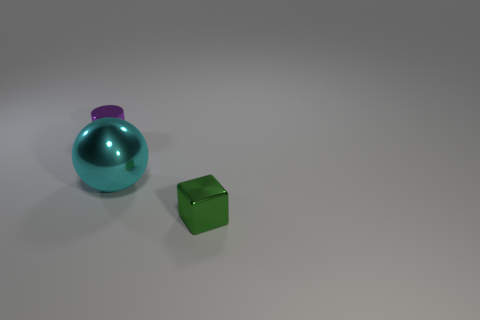The small thing right of the big cyan shiny sphere is what color?
Keep it short and to the point. Green. Are there more tiny shiny things left of the green metal object than tiny purple rubber blocks?
Provide a short and direct response. Yes. What is the color of the tiny block?
Offer a very short reply. Green. What is the shape of the small metal object that is on the left side of the small metal thing right of the tiny object that is behind the small green metal block?
Provide a short and direct response. Cylinder. There is a thing that is on the right side of the cylinder and left of the tiny green metal object; what material is it?
Keep it short and to the point. Metal. There is a small metal object on the right side of the tiny shiny thing left of the cyan metallic object; what is its shape?
Give a very brief answer. Cube. Does the green object have the same size as the object that is behind the sphere?
Provide a short and direct response. Yes. What number of tiny things are either red matte cylinders or spheres?
Keep it short and to the point. 0. Are there more tiny purple cylinders than tiny things?
Your answer should be very brief. No. There is a small metallic object that is in front of the tiny purple cylinder that is to the left of the big metallic object; how many cyan objects are on the left side of it?
Your response must be concise. 1. 